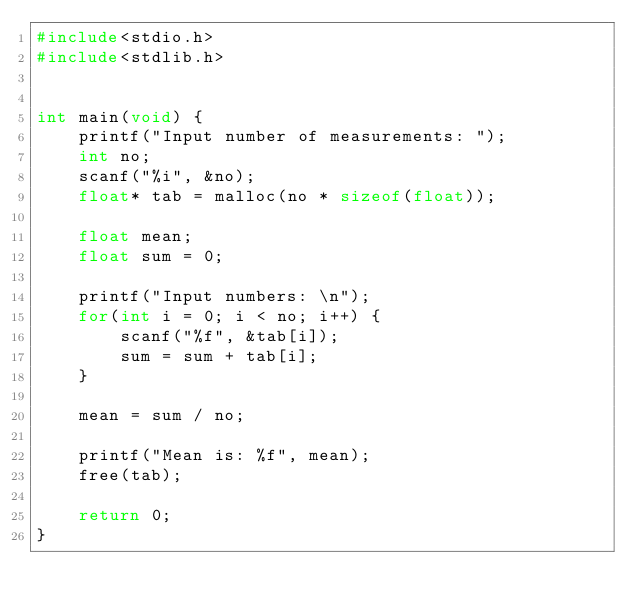<code> <loc_0><loc_0><loc_500><loc_500><_C_>#include<stdio.h>
#include<stdlib.h>


int main(void) {
    printf("Input number of measurements: ");
    int no;
    scanf("%i", &no);
    float* tab = malloc(no * sizeof(float));

    float mean;
    float sum = 0;

    printf("Input numbers: \n");
    for(int i = 0; i < no; i++) {
        scanf("%f", &tab[i]);
        sum = sum + tab[i];
    }

    mean = sum / no;

    printf("Mean is: %f", mean);
    free(tab);
    
    return 0;
}</code> 